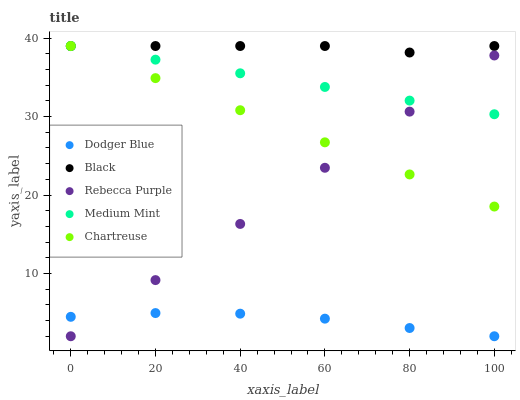Does Dodger Blue have the minimum area under the curve?
Answer yes or no. Yes. Does Black have the maximum area under the curve?
Answer yes or no. Yes. Does Chartreuse have the minimum area under the curve?
Answer yes or no. No. Does Chartreuse have the maximum area under the curve?
Answer yes or no. No. Is Rebecca Purple the smoothest?
Answer yes or no. Yes. Is Black the roughest?
Answer yes or no. Yes. Is Chartreuse the smoothest?
Answer yes or no. No. Is Chartreuse the roughest?
Answer yes or no. No. Does Dodger Blue have the lowest value?
Answer yes or no. Yes. Does Chartreuse have the lowest value?
Answer yes or no. No. Does Chartreuse have the highest value?
Answer yes or no. Yes. Does Dodger Blue have the highest value?
Answer yes or no. No. Is Dodger Blue less than Medium Mint?
Answer yes or no. Yes. Is Chartreuse greater than Dodger Blue?
Answer yes or no. Yes. Does Medium Mint intersect Black?
Answer yes or no. Yes. Is Medium Mint less than Black?
Answer yes or no. No. Is Medium Mint greater than Black?
Answer yes or no. No. Does Dodger Blue intersect Medium Mint?
Answer yes or no. No. 